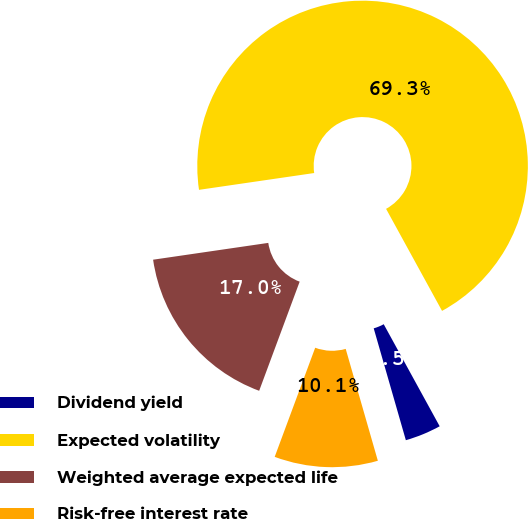Convert chart to OTSL. <chart><loc_0><loc_0><loc_500><loc_500><pie_chart><fcel>Dividend yield<fcel>Expected volatility<fcel>Weighted average expected life<fcel>Risk-free interest rate<nl><fcel>3.53%<fcel>69.33%<fcel>17.04%<fcel>10.11%<nl></chart> 